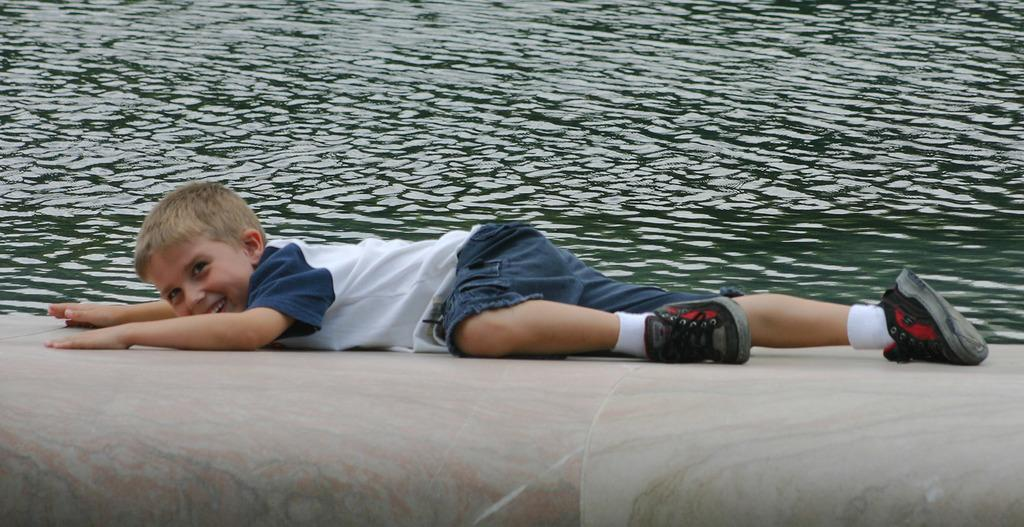Who is present in the image? There is a boy in the image. What is the boy's position in the image? The boy is lying on a surface. What can be seen in the background of the image? There is water visible in the image. Where is the bat located in the image? There is no bat present in the image. What type of park can be seen in the image? There is no park present in the image. 